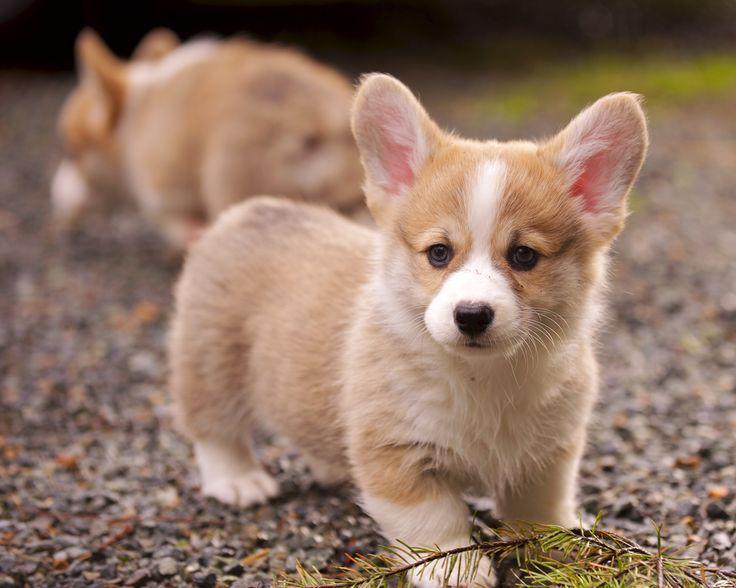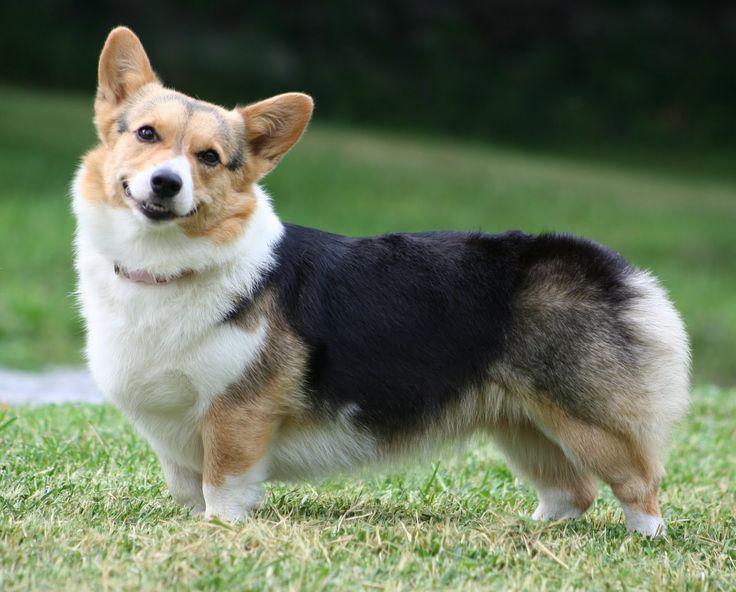The first image is the image on the left, the second image is the image on the right. Analyze the images presented: Is the assertion "One image shows a corgi standing with its body turned leftward and its smiling face turned to the camera." valid? Answer yes or no. Yes. The first image is the image on the left, the second image is the image on the right. For the images displayed, is the sentence "There are exactly 3 dogs, and they are all outside." factually correct? Answer yes or no. Yes. 